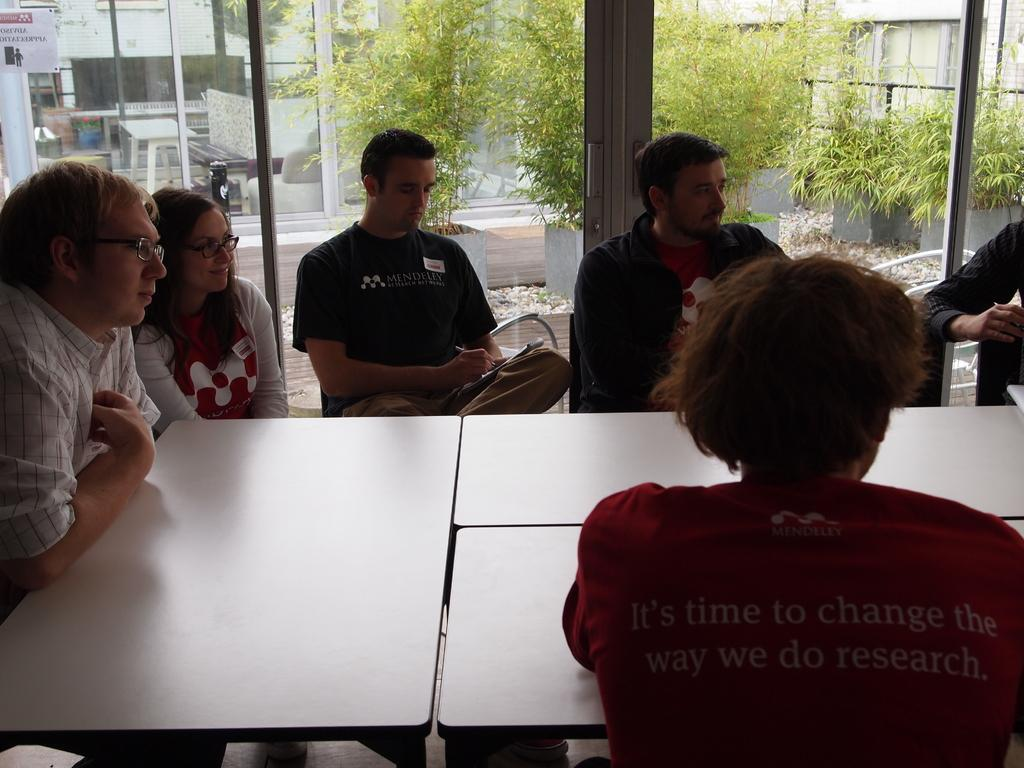What is happening in the image involving a group of people? There is a group of people in the image, and they are sitting. How are the people in the image feeling? The people in the image are smiling, which suggests they are happy or enjoying themselves. What can be seen in the background of the image? There is a window in the backdrop of the image. What type of slope can be seen in the image? There is no slope present in the image; it features a group of people sitting and smiling. What is the value of the wrench in the image? There is no wrench present in the image, so its value cannot be determined. 